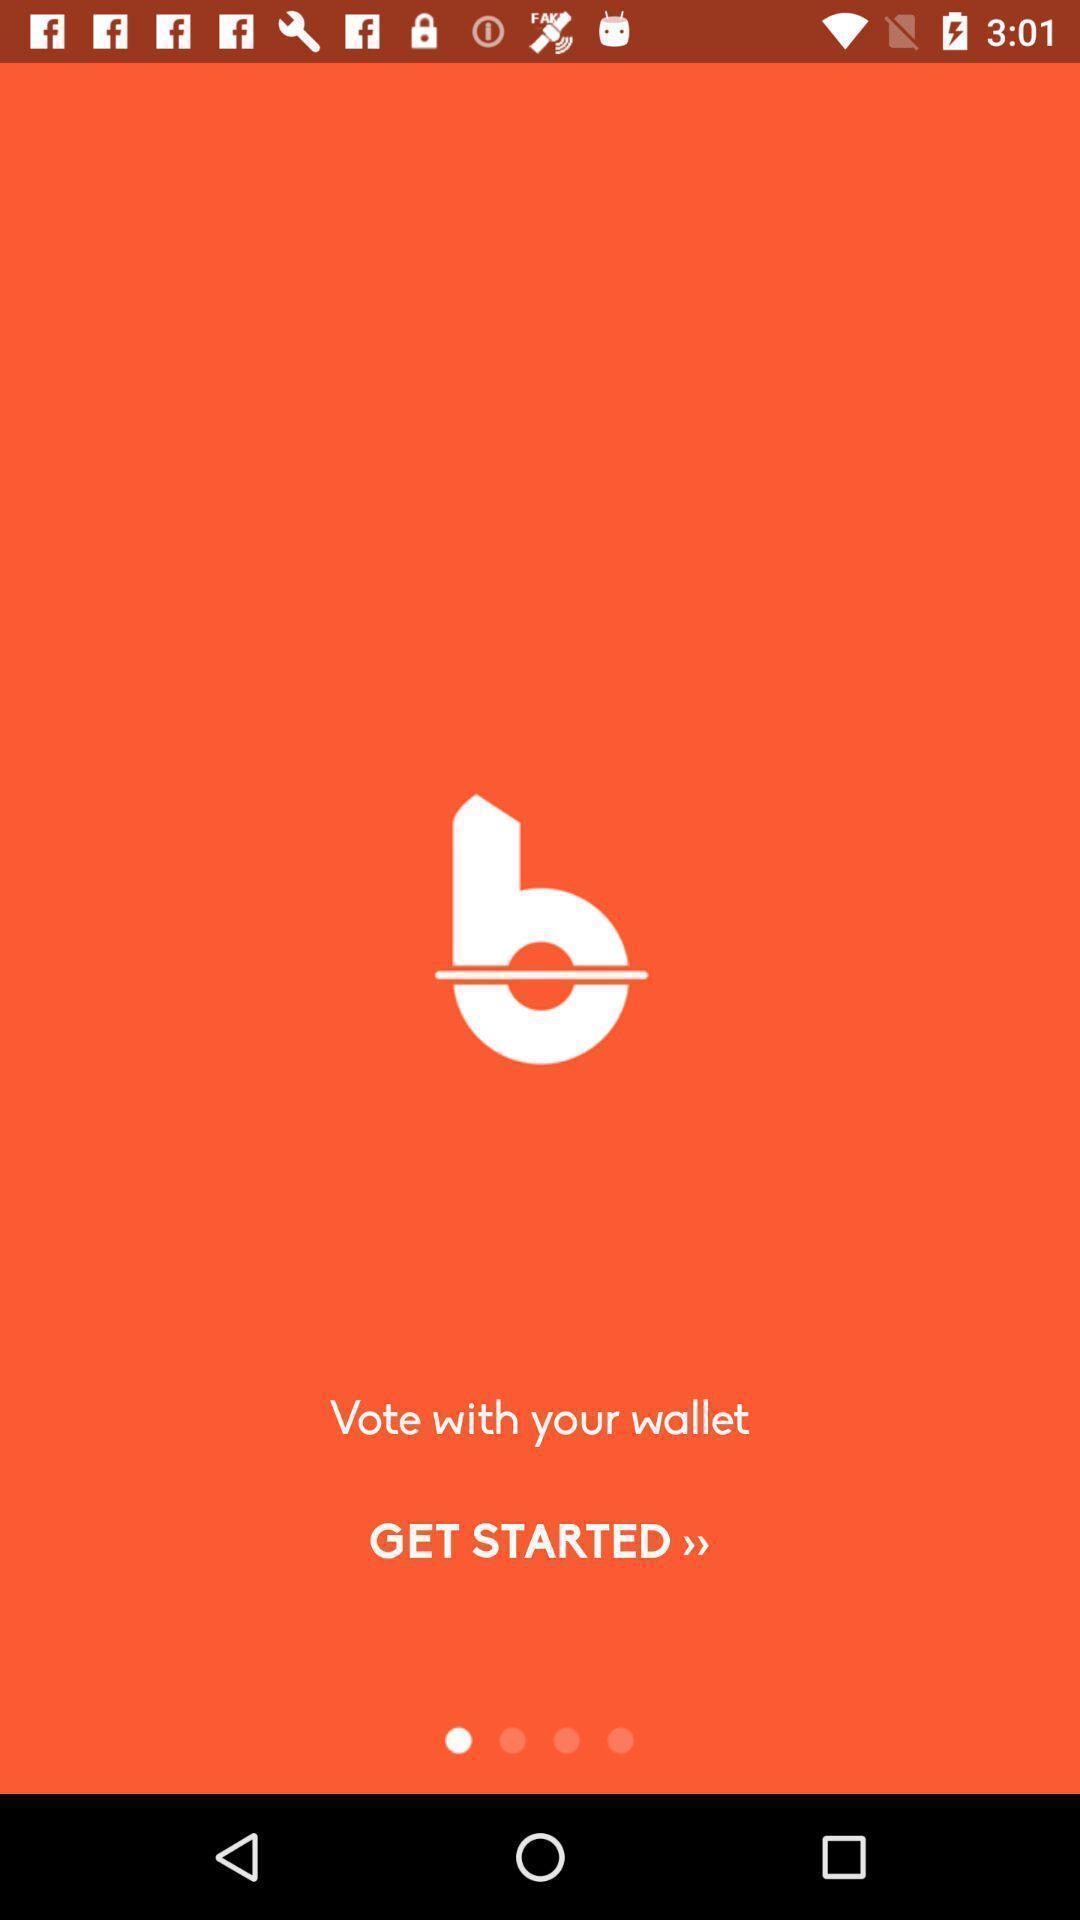What can you discern from this picture? Welcome page. 